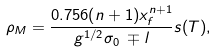Convert formula to latex. <formula><loc_0><loc_0><loc_500><loc_500>\rho _ { M } = \frac { 0 . 7 5 6 ( n + 1 ) x _ { f } ^ { n + 1 } } { g ^ { 1 / 2 } \sigma _ { 0 } \, \mp l } s ( T ) ,</formula> 